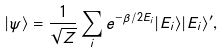<formula> <loc_0><loc_0><loc_500><loc_500>| \psi \rangle = \frac { 1 } { \sqrt { Z } } \sum _ { i } e ^ { - \beta / 2 E _ { i } } | E _ { i } \rangle | E _ { i } \rangle ^ { \prime } ,</formula> 